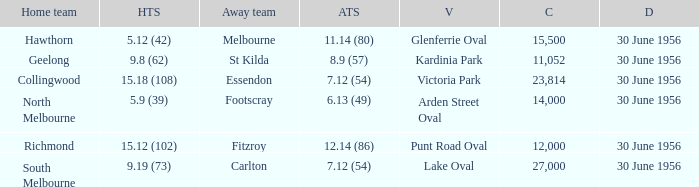Can you give me this table as a dict? {'header': ['Home team', 'HTS', 'Away team', 'ATS', 'V', 'C', 'D'], 'rows': [['Hawthorn', '5.12 (42)', 'Melbourne', '11.14 (80)', 'Glenferrie Oval', '15,500', '30 June 1956'], ['Geelong', '9.8 (62)', 'St Kilda', '8.9 (57)', 'Kardinia Park', '11,052', '30 June 1956'], ['Collingwood', '15.18 (108)', 'Essendon', '7.12 (54)', 'Victoria Park', '23,814', '30 June 1956'], ['North Melbourne', '5.9 (39)', 'Footscray', '6.13 (49)', 'Arden Street Oval', '14,000', '30 June 1956'], ['Richmond', '15.12 (102)', 'Fitzroy', '12.14 (86)', 'Punt Road Oval', '12,000', '30 June 1956'], ['South Melbourne', '9.19 (73)', 'Carlton', '7.12 (54)', 'Lake Oval', '27,000', '30 June 1956']]} What is the home team score when the away team is Melbourne? 5.12 (42). 